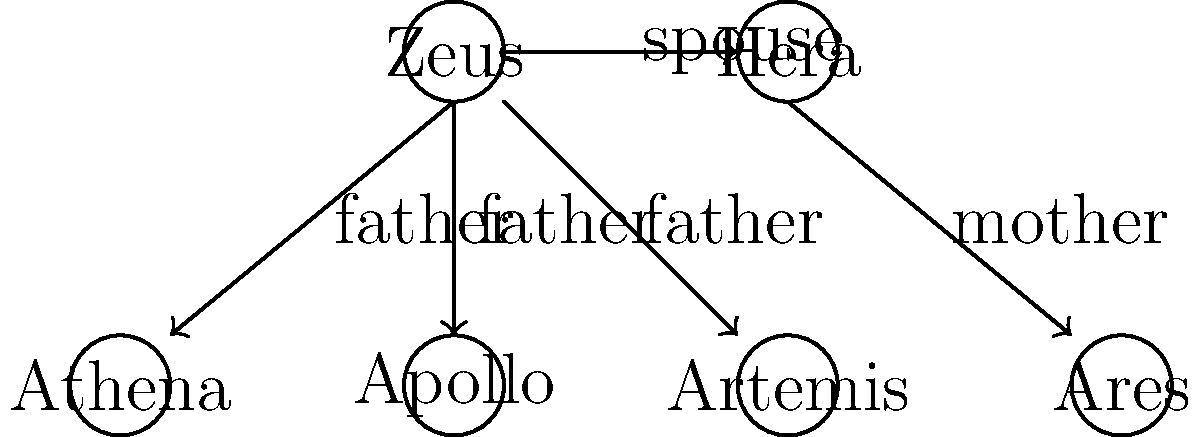Based on the family tree diagram of Greek gods and goddesses, which deity is both a sibling and a half-sibling to the others? Explain your reasoning, considering the importance of understanding complex familial relationships in Greek mythology for promoting diversity in classical studies. To answer this question, let's analyze the family tree step-by-step:

1. Zeus is shown as the father of Athena, Apollo, and Artemis.
2. Hera is shown as the mother of Ares and the spouse of Zeus.
3. This means that Ares is a full sibling to neither Athena, Apollo, nor Artemis.
4. Apollo and Artemis share both parents (Zeus as their father, and an implied mother not shown in the diagram, traditionally Leto).
5. Athena, according to myth, was born from Zeus's head and has no mother shown in the diagram.

Therefore, Apollo is both a sibling and a half-sibling to the others:
- Full sibling to Artemis (sharing both parents)
- Half-sibling to Ares (sharing Zeus as a father)
- Half-sibling to Athena (sharing Zeus as a father)

Understanding these complex relationships is crucial for promoting diversity in classical studies because:
1. It highlights the non-traditional family structures in Greek mythology, challenging modern assumptions about family.
2. It demonstrates the complexity of divine relationships, which often mirror human social structures and power dynamics.
3. It provides opportunities to discuss gender roles and expectations in ancient Greek culture.
4. It allows for exploration of different cultural perspectives on kinship and family bonds.

By analyzing these relationships, we can engage students in discussions about diverse family structures, gender roles, and cultural differences, promoting a more inclusive approach to classical studies.
Answer: Apollo 